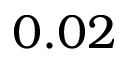<formula> <loc_0><loc_0><loc_500><loc_500>0 . 0 2</formula> 